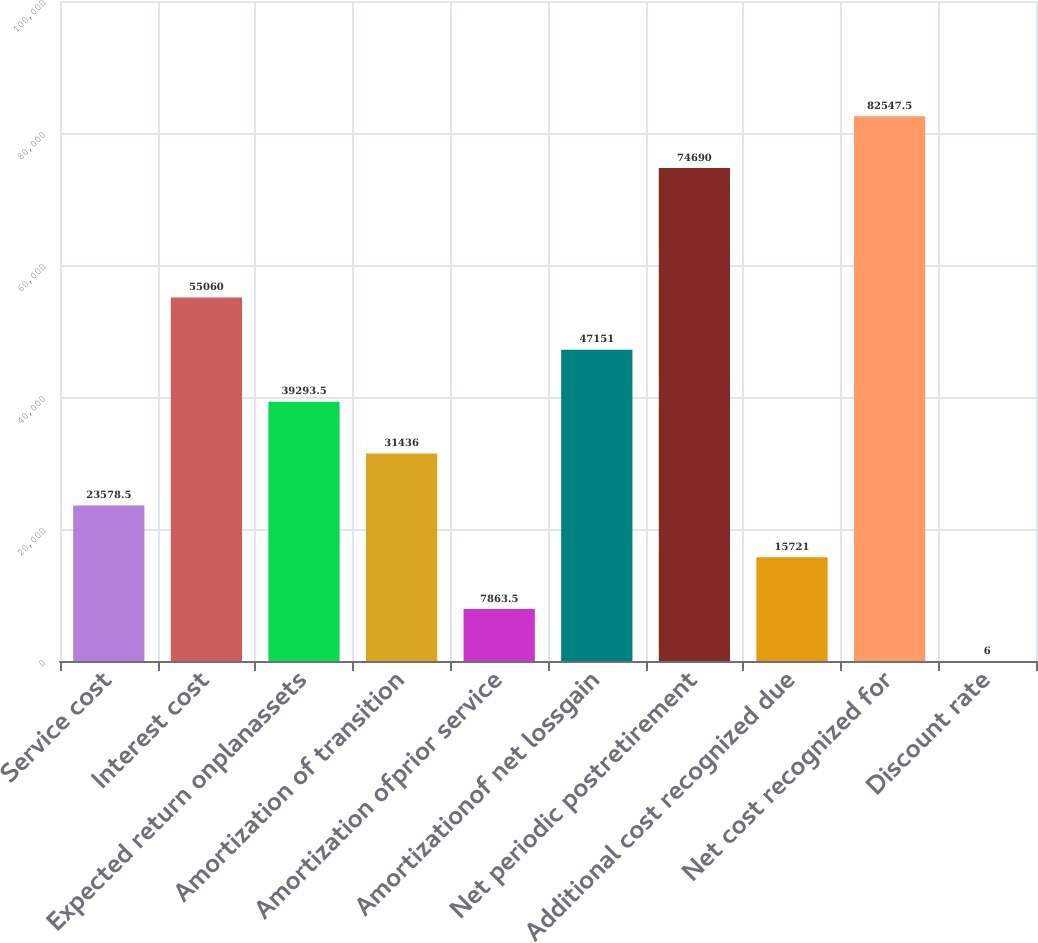<chart> <loc_0><loc_0><loc_500><loc_500><bar_chart><fcel>Service cost<fcel>Interest cost<fcel>Expected return onplanassets<fcel>Amortization of transition<fcel>Amortization ofprior service<fcel>Amortizationof net lossgain<fcel>Net periodic postretirement<fcel>Additional cost recognized due<fcel>Net cost recognized for<fcel>Discount rate<nl><fcel>23578.5<fcel>55060<fcel>39293.5<fcel>31436<fcel>7863.5<fcel>47151<fcel>74690<fcel>15721<fcel>82547.5<fcel>6<nl></chart> 